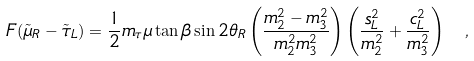Convert formula to latex. <formula><loc_0><loc_0><loc_500><loc_500>F ( \tilde { \mu } _ { R } - \tilde { \tau } _ { L } ) = \frac { 1 } { 2 } m _ { \tau } \mu \tan \beta \sin 2 \theta _ { R } \left ( \frac { m _ { 2 } ^ { 2 } - m _ { 3 } ^ { 2 } } { m _ { 2 } ^ { 2 } m _ { 3 } ^ { 2 } } \right ) \left ( \frac { s _ { L } ^ { 2 } } { m _ { 2 } ^ { 2 } } + \frac { c _ { L } ^ { 2 } } { m _ { 3 } ^ { 2 } } \right ) \ ,</formula> 